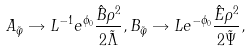<formula> <loc_0><loc_0><loc_500><loc_500>A _ { \tilde { \varphi } } \rightarrow L ^ { - 1 } e ^ { \phi _ { 0 } } \frac { \hat { B } \rho ^ { 2 } } { 2 \tilde { \Lambda } } , B _ { \tilde { \varphi } } \rightarrow L e ^ { - \phi _ { 0 } } \frac { \hat { E } \rho ^ { 2 } } { 2 \tilde { \Psi } } ,</formula> 